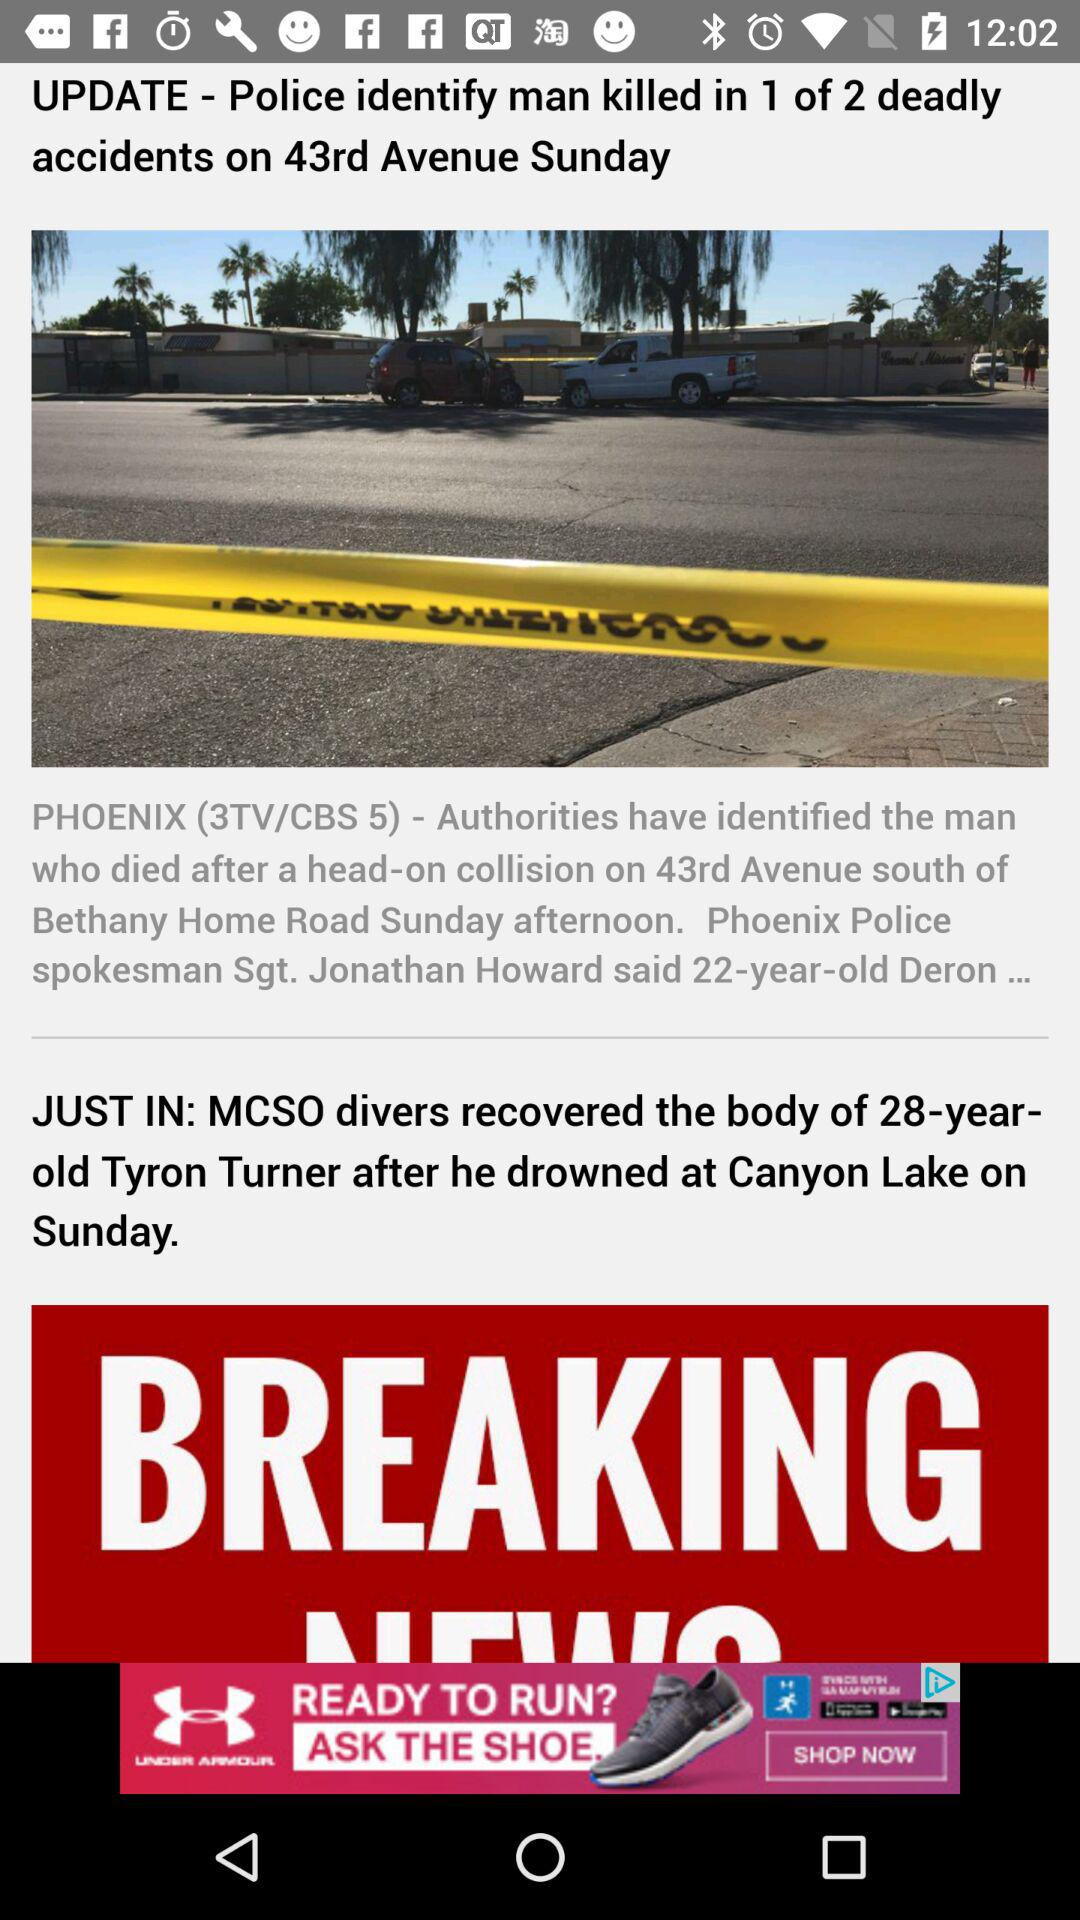What is the age of Tyron Turner? Tyron Turner is 28 years old. 